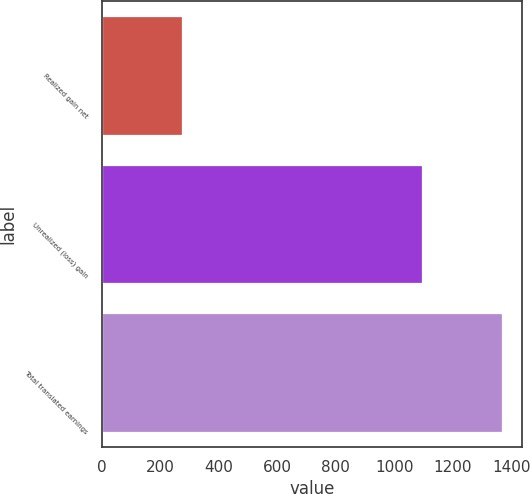<chart> <loc_0><loc_0><loc_500><loc_500><bar_chart><fcel>Realized gain net<fcel>Unrealized (loss) gain<fcel>Total translated earnings<nl><fcel>274<fcel>1095<fcel>1369<nl></chart> 